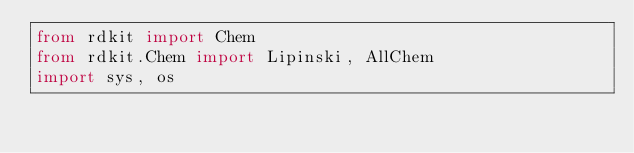<code> <loc_0><loc_0><loc_500><loc_500><_Python_>from rdkit import Chem
from rdkit.Chem import Lipinski, AllChem
import sys, os
</code> 